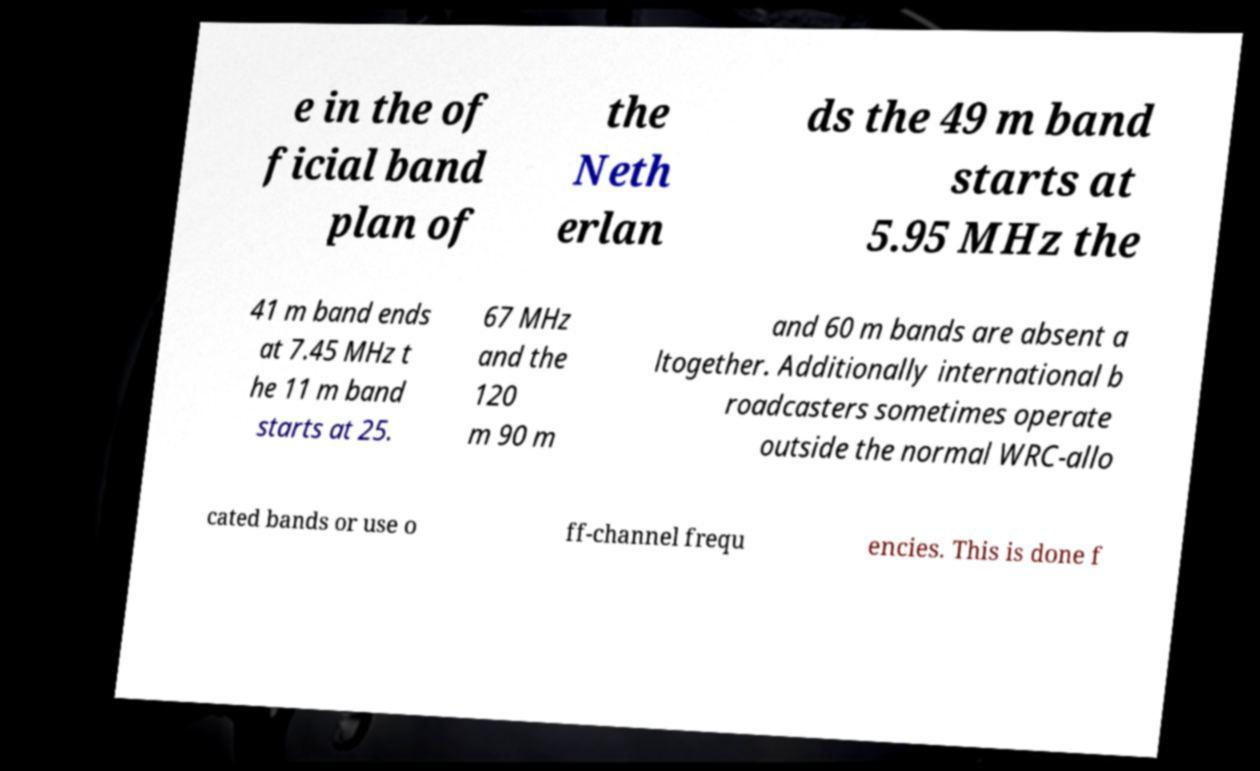I need the written content from this picture converted into text. Can you do that? e in the of ficial band plan of the Neth erlan ds the 49 m band starts at 5.95 MHz the 41 m band ends at 7.45 MHz t he 11 m band starts at 25. 67 MHz and the 120 m 90 m and 60 m bands are absent a ltogether. Additionally international b roadcasters sometimes operate outside the normal WRC-allo cated bands or use o ff-channel frequ encies. This is done f 